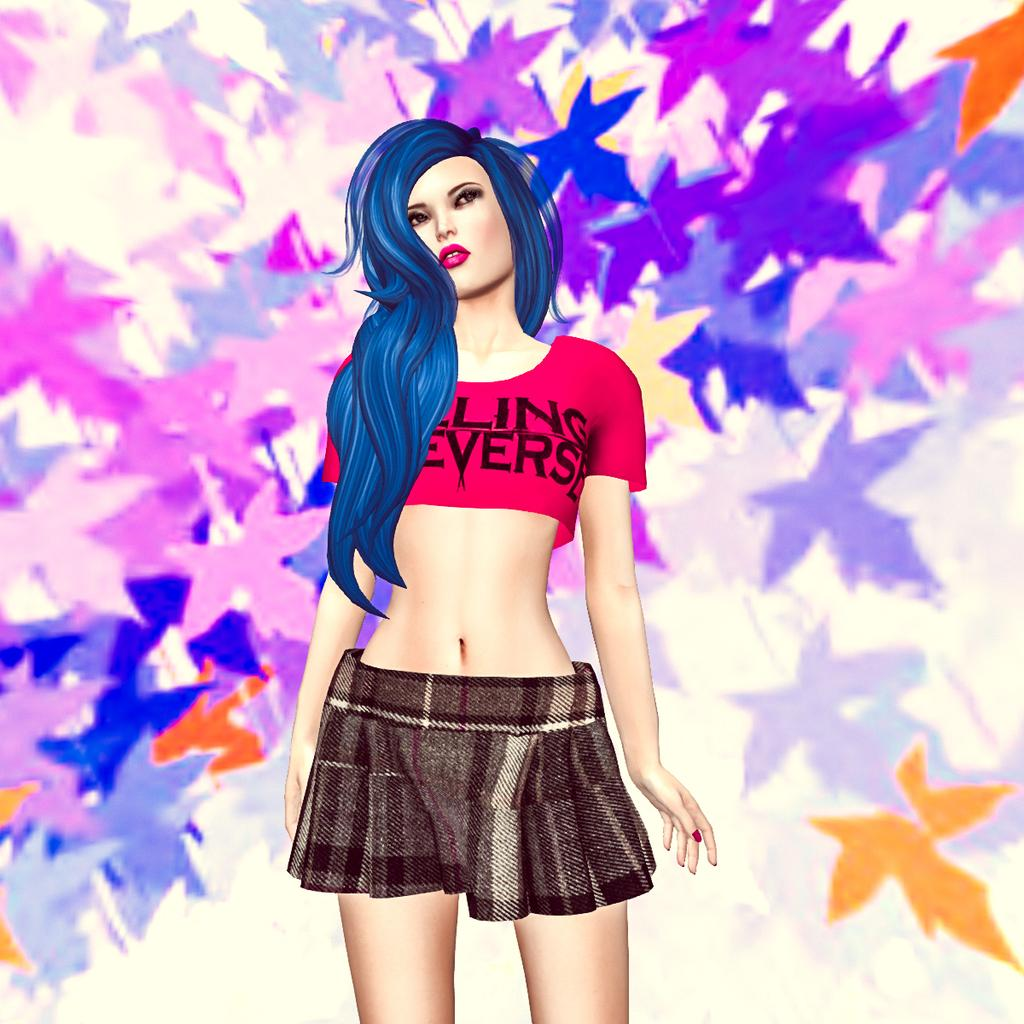<image>
Share a concise interpretation of the image provided. A cartoon girl with blue hair has the word evers on a red shirt, but the word could be different as her hair cuts off the first few letters. 